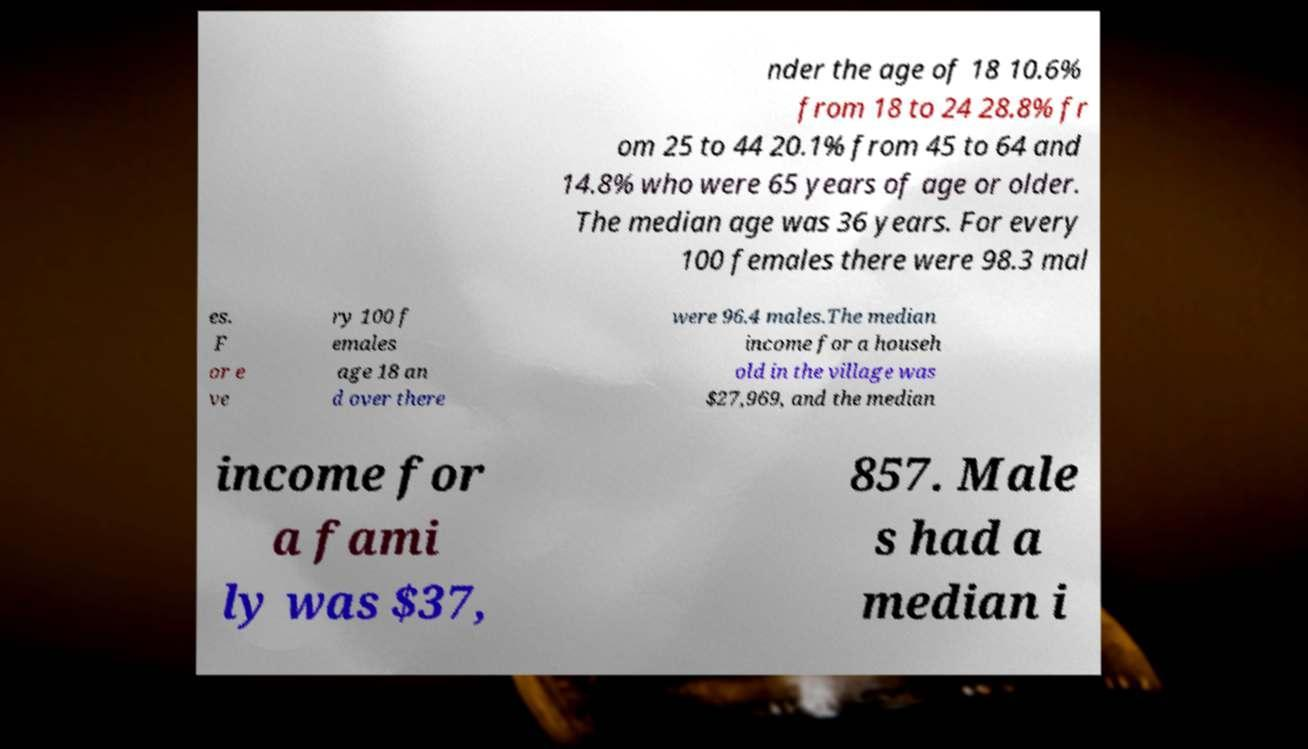What messages or text are displayed in this image? I need them in a readable, typed format. nder the age of 18 10.6% from 18 to 24 28.8% fr om 25 to 44 20.1% from 45 to 64 and 14.8% who were 65 years of age or older. The median age was 36 years. For every 100 females there were 98.3 mal es. F or e ve ry 100 f emales age 18 an d over there were 96.4 males.The median income for a househ old in the village was $27,969, and the median income for a fami ly was $37, 857. Male s had a median i 